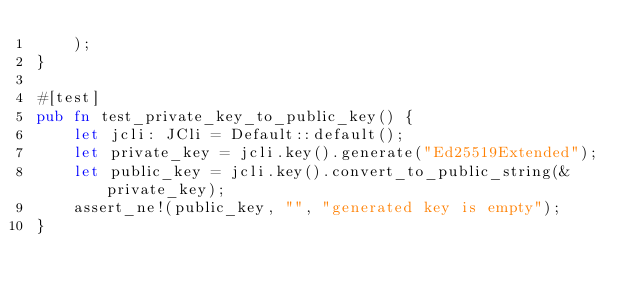Convert code to text. <code><loc_0><loc_0><loc_500><loc_500><_Rust_>    );
}

#[test]
pub fn test_private_key_to_public_key() {
    let jcli: JCli = Default::default();
    let private_key = jcli.key().generate("Ed25519Extended");
    let public_key = jcli.key().convert_to_public_string(&private_key);
    assert_ne!(public_key, "", "generated key is empty");
}
</code> 